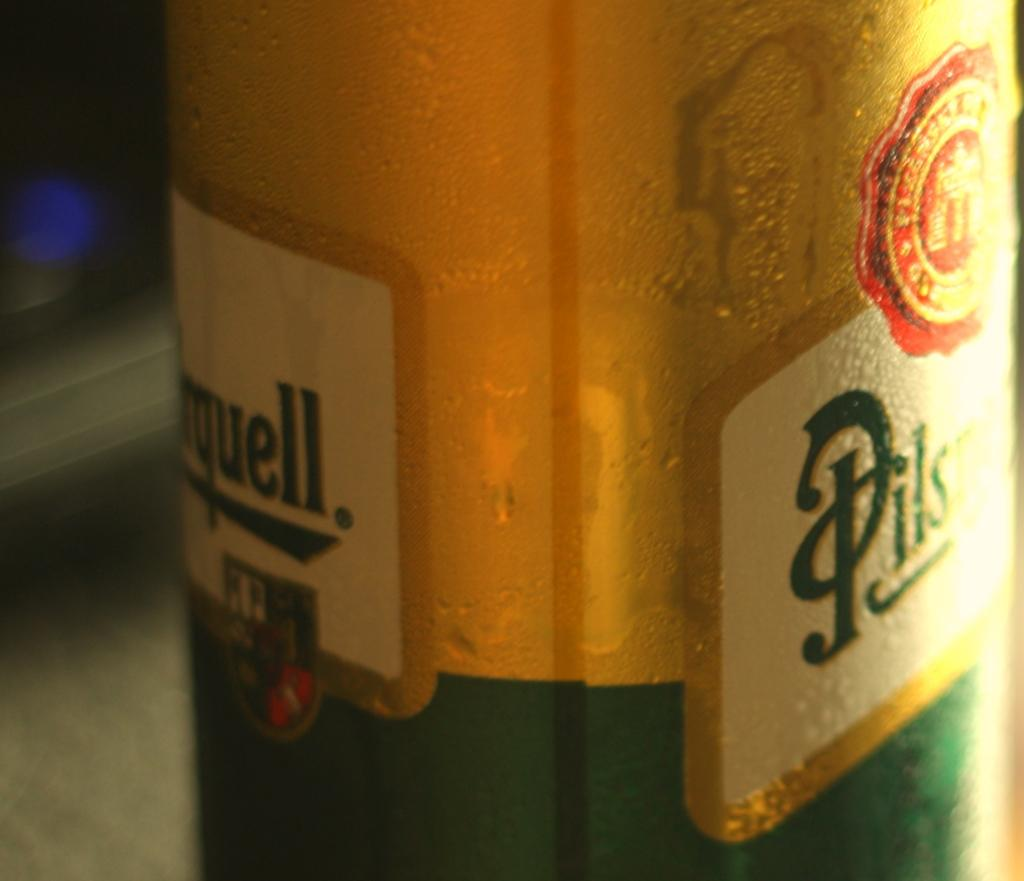What object can be seen in the image? There is a bottle in the image. Where is the bottle located? The bottle is placed on a surface. What type of cakes can be seen sinking in the quicksand in the image? There is no quicksand or cakes present in the image; it only features a bottle placed on a surface. 